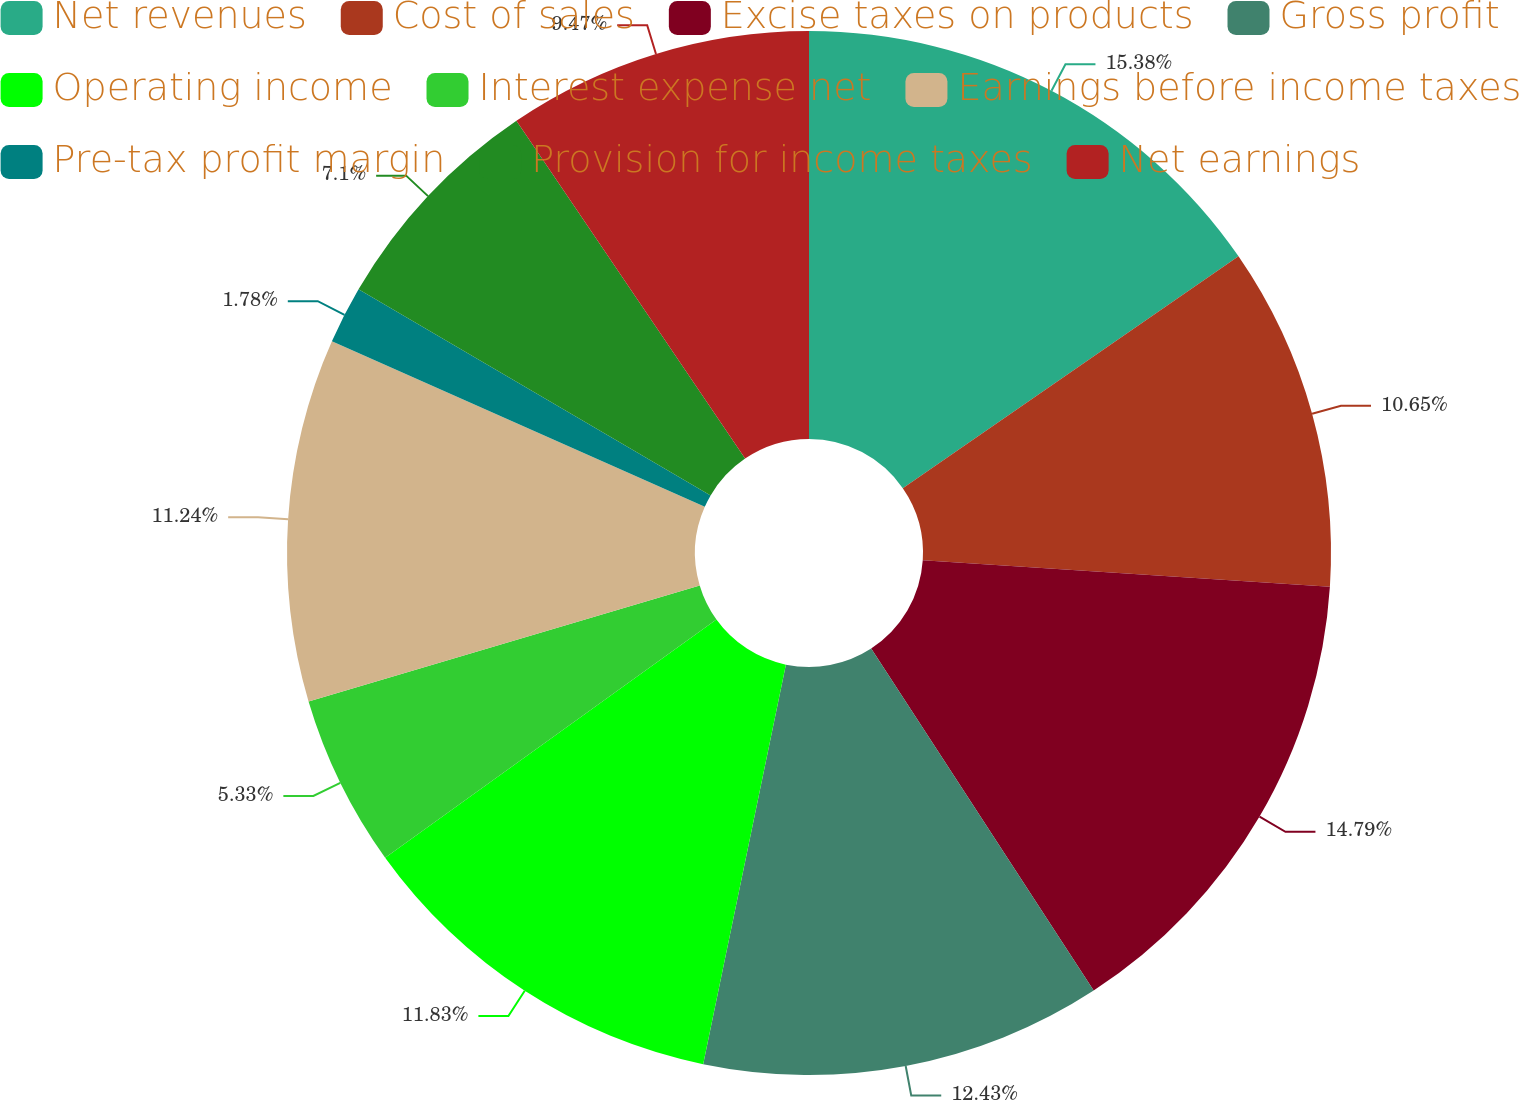<chart> <loc_0><loc_0><loc_500><loc_500><pie_chart><fcel>Net revenues<fcel>Cost of sales<fcel>Excise taxes on products<fcel>Gross profit<fcel>Operating income<fcel>Interest expense net<fcel>Earnings before income taxes<fcel>Pre-tax profit margin<fcel>Provision for income taxes<fcel>Net earnings<nl><fcel>15.38%<fcel>10.65%<fcel>14.79%<fcel>12.43%<fcel>11.83%<fcel>5.33%<fcel>11.24%<fcel>1.78%<fcel>7.1%<fcel>9.47%<nl></chart> 